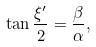Convert formula to latex. <formula><loc_0><loc_0><loc_500><loc_500>\tan { \frac { \xi ^ { \prime } } { 2 } } = \frac { \beta } { \alpha } ,</formula> 